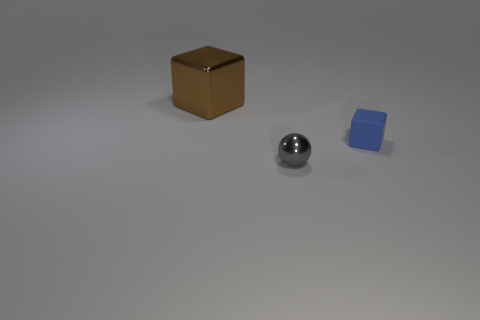Add 2 small brown rubber blocks. How many objects exist? 5 Subtract all blocks. How many objects are left? 1 Subtract all small blue cubes. Subtract all large shiny blocks. How many objects are left? 1 Add 1 large brown metallic blocks. How many large brown metallic blocks are left? 2 Add 2 large blue matte things. How many large blue matte things exist? 2 Subtract 1 blue cubes. How many objects are left? 2 